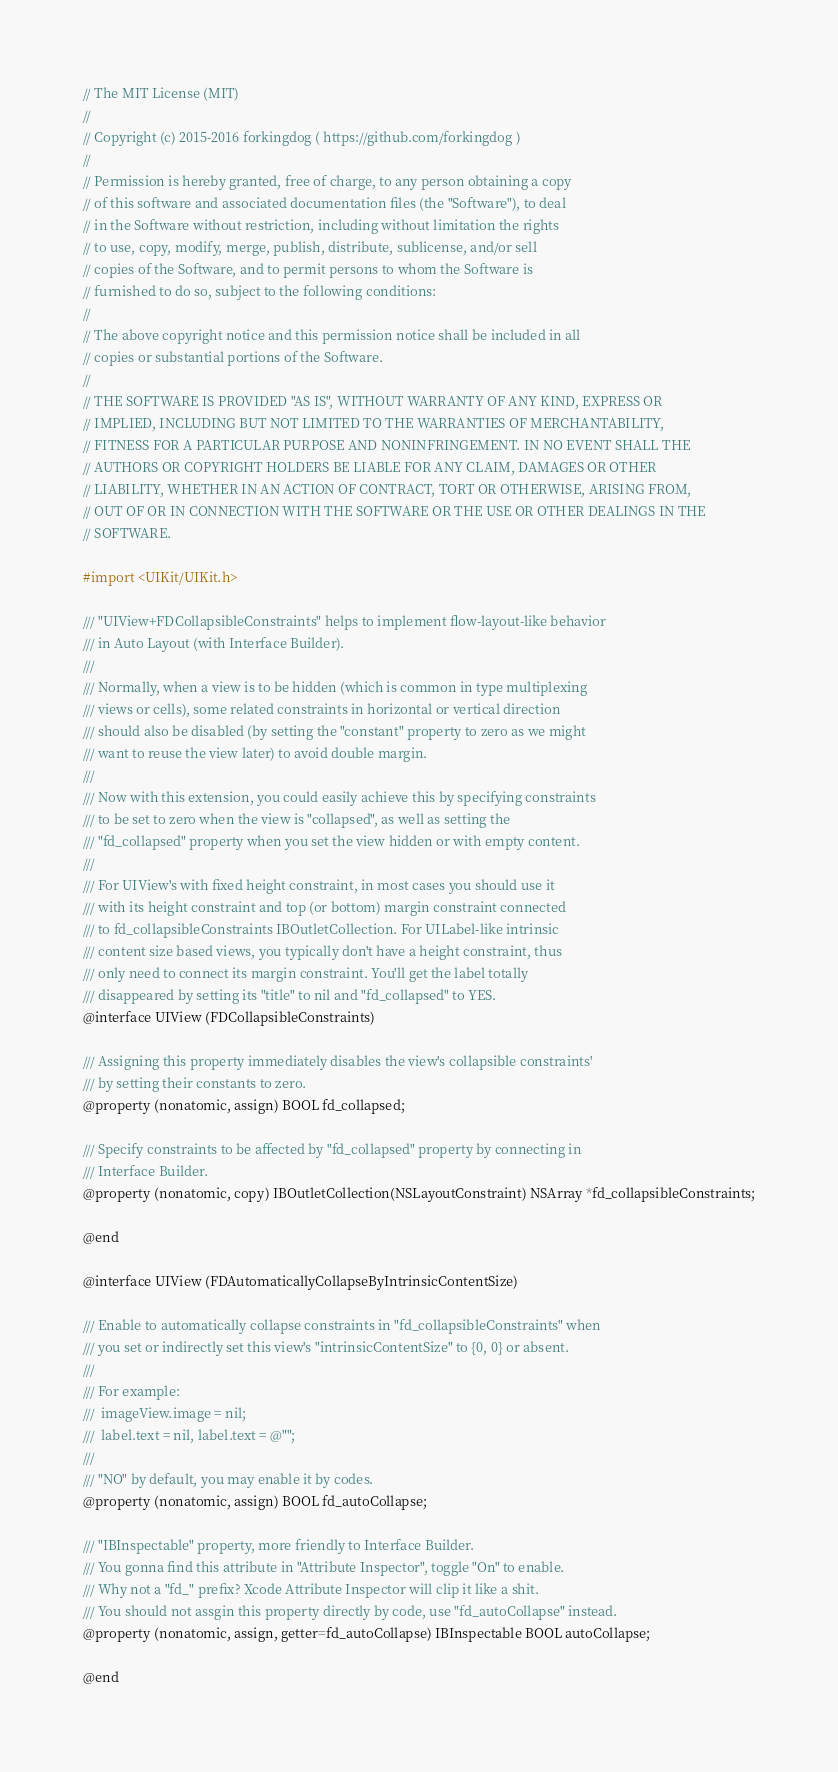<code> <loc_0><loc_0><loc_500><loc_500><_C_>// The MIT License (MIT)
//
// Copyright (c) 2015-2016 forkingdog ( https://github.com/forkingdog )
//
// Permission is hereby granted, free of charge, to any person obtaining a copy
// of this software and associated documentation files (the "Software"), to deal
// in the Software without restriction, including without limitation the rights
// to use, copy, modify, merge, publish, distribute, sublicense, and/or sell
// copies of the Software, and to permit persons to whom the Software is
// furnished to do so, subject to the following conditions:
//
// The above copyright notice and this permission notice shall be included in all
// copies or substantial portions of the Software.
//
// THE SOFTWARE IS PROVIDED "AS IS", WITHOUT WARRANTY OF ANY KIND, EXPRESS OR
// IMPLIED, INCLUDING BUT NOT LIMITED TO THE WARRANTIES OF MERCHANTABILITY,
// FITNESS FOR A PARTICULAR PURPOSE AND NONINFRINGEMENT. IN NO EVENT SHALL THE
// AUTHORS OR COPYRIGHT HOLDERS BE LIABLE FOR ANY CLAIM, DAMAGES OR OTHER
// LIABILITY, WHETHER IN AN ACTION OF CONTRACT, TORT OR OTHERWISE, ARISING FROM,
// OUT OF OR IN CONNECTION WITH THE SOFTWARE OR THE USE OR OTHER DEALINGS IN THE
// SOFTWARE.

#import <UIKit/UIKit.h>

/// "UIView+FDCollapsibleConstraints" helps to implement flow-layout-like behavior
/// in Auto Layout (with Interface Builder).
///
/// Normally, when a view is to be hidden (which is common in type multiplexing
/// views or cells), some related constraints in horizontal or vertical direction
/// should also be disabled (by setting the "constant" property to zero as we might
/// want to reuse the view later) to avoid double margin.
///
/// Now with this extension, you could easily achieve this by specifying constraints
/// to be set to zero when the view is "collapsed", as well as setting the
/// "fd_collapsed" property when you set the view hidden or with empty content.
///
/// For UIView's with fixed height constraint, in most cases you should use it
/// with its height constraint and top (or bottom) margin constraint connected
/// to fd_collapsibleConstraints IBOutletCollection. For UILabel-like intrinsic
/// content size based views, you typically don't have a height constraint, thus
/// only need to connect its margin constraint. You'll get the label totally
/// disappeared by setting its "title" to nil and "fd_collapsed" to YES.
@interface UIView (FDCollapsibleConstraints)

/// Assigning this property immediately disables the view's collapsible constraints'
/// by setting their constants to zero.
@property (nonatomic, assign) BOOL fd_collapsed;

/// Specify constraints to be affected by "fd_collapsed" property by connecting in
/// Interface Builder.
@property (nonatomic, copy) IBOutletCollection(NSLayoutConstraint) NSArray *fd_collapsibleConstraints;

@end

@interface UIView (FDAutomaticallyCollapseByIntrinsicContentSize)

/// Enable to automatically collapse constraints in "fd_collapsibleConstraints" when
/// you set or indirectly set this view's "intrinsicContentSize" to {0, 0} or absent.
///
/// For example:
///  imageView.image = nil;
///  label.text = nil, label.text = @"";
///
/// "NO" by default, you may enable it by codes.
@property (nonatomic, assign) BOOL fd_autoCollapse;

/// "IBInspectable" property, more friendly to Interface Builder.
/// You gonna find this attribute in "Attribute Inspector", toggle "On" to enable.
/// Why not a "fd_" prefix? Xcode Attribute Inspector will clip it like a shit.
/// You should not assgin this property directly by code, use "fd_autoCollapse" instead.
@property (nonatomic, assign, getter=fd_autoCollapse) IBInspectable BOOL autoCollapse;

@end
</code> 